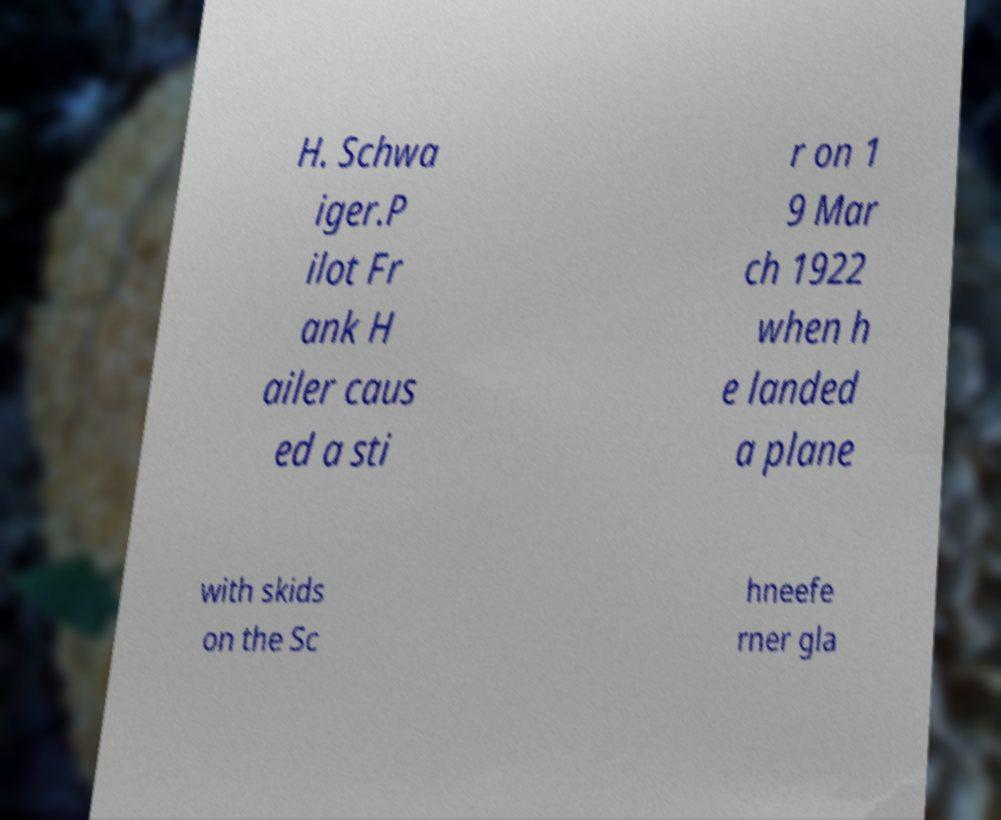Please identify and transcribe the text found in this image. H. Schwa iger.P ilot Fr ank H ailer caus ed a sti r on 1 9 Mar ch 1922 when h e landed a plane with skids on the Sc hneefe rner gla 